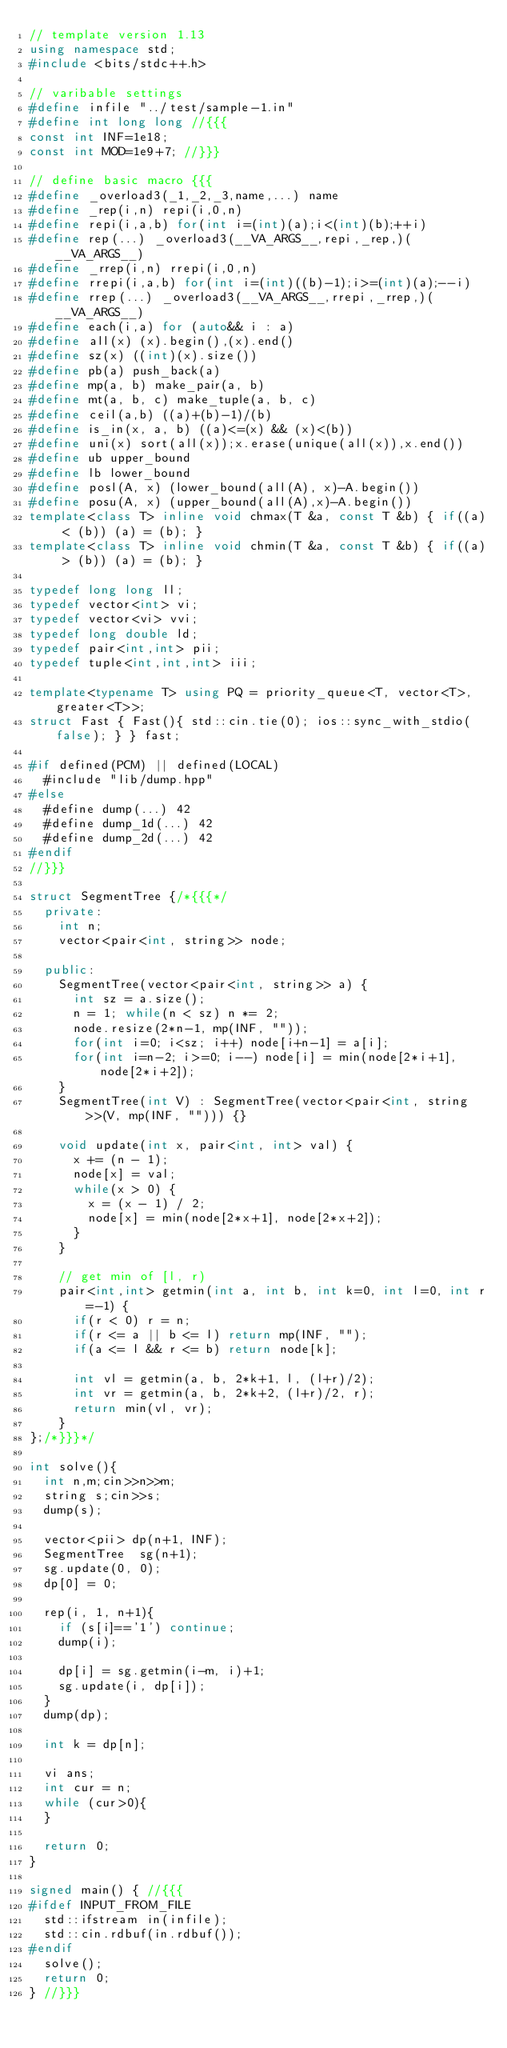<code> <loc_0><loc_0><loc_500><loc_500><_C++_>// template version 1.13
using namespace std;
#include <bits/stdc++.h>

// varibable settings
#define infile "../test/sample-1.in"
#define int long long //{{{
const int INF=1e18;
const int MOD=1e9+7; //}}}

// define basic macro {{{
#define _overload3(_1,_2,_3,name,...) name
#define _rep(i,n) repi(i,0,n)
#define repi(i,a,b) for(int i=(int)(a);i<(int)(b);++i)
#define rep(...) _overload3(__VA_ARGS__,repi,_rep,)(__VA_ARGS__)
#define _rrep(i,n) rrepi(i,0,n)
#define rrepi(i,a,b) for(int i=(int)((b)-1);i>=(int)(a);--i)
#define rrep(...) _overload3(__VA_ARGS__,rrepi,_rrep,)(__VA_ARGS__)
#define each(i,a) for (auto&& i : a)
#define all(x) (x).begin(),(x).end()
#define sz(x) ((int)(x).size())
#define pb(a) push_back(a)
#define mp(a, b) make_pair(a, b)
#define mt(a, b, c) make_tuple(a, b, c)
#define ceil(a,b) ((a)+(b)-1)/(b)
#define is_in(x, a, b) ((a)<=(x) && (x)<(b))
#define uni(x) sort(all(x));x.erase(unique(all(x)),x.end())
#define ub upper_bound
#define lb lower_bound
#define posl(A, x) (lower_bound(all(A), x)-A.begin())
#define posu(A, x) (upper_bound(all(A),x)-A.begin())
template<class T> inline void chmax(T &a, const T &b) { if((a) < (b)) (a) = (b); }
template<class T> inline void chmin(T &a, const T &b) { if((a) > (b)) (a) = (b); }

typedef long long ll;
typedef vector<int> vi;
typedef vector<vi> vvi;
typedef long double ld;
typedef pair<int,int> pii;
typedef tuple<int,int,int> iii;

template<typename T> using PQ = priority_queue<T, vector<T>, greater<T>>;
struct Fast { Fast(){ std::cin.tie(0); ios::sync_with_stdio(false); } } fast;

#if defined(PCM) || defined(LOCAL)
  #include "lib/dump.hpp"
#else
  #define dump(...) 42
  #define dump_1d(...) 42
  #define dump_2d(...) 42
#endif
//}}}

struct SegmentTree {/*{{{*/
  private:
    int n;
    vector<pair<int, string>> node;

  public:
    SegmentTree(vector<pair<int, string>> a) {
      int sz = a.size();
      n = 1; while(n < sz) n *= 2;
      node.resize(2*n-1, mp(INF, ""));
      for(int i=0; i<sz; i++) node[i+n-1] = a[i];
      for(int i=n-2; i>=0; i--) node[i] = min(node[2*i+1], node[2*i+2]);
    }
    SegmentTree(int V) : SegmentTree(vector<pair<int, string>>(V, mp(INF, ""))) {}

    void update(int x, pair<int, int> val) {
      x += (n - 1);
      node[x] = val;
      while(x > 0) {
        x = (x - 1) / 2;
        node[x] = min(node[2*x+1], node[2*x+2]);
      }
    }

    // get min of [l, r)
    pair<int,int> getmin(int a, int b, int k=0, int l=0, int r=-1) {
      if(r < 0) r = n;
      if(r <= a || b <= l) return mp(INF, "");
      if(a <= l && r <= b) return node[k];

      int vl = getmin(a, b, 2*k+1, l, (l+r)/2);
      int vr = getmin(a, b, 2*k+2, (l+r)/2, r);
      return min(vl, vr);
    }
};/*}}}*/

int solve(){
  int n,m;cin>>n>>m;
  string s;cin>>s;
  dump(s);

  vector<pii> dp(n+1, INF);
  SegmentTree  sg(n+1);
  sg.update(0, 0);
  dp[0] = 0;

  rep(i, 1, n+1){
    if (s[i]=='1') continue;
    dump(i);

    dp[i] = sg.getmin(i-m, i)+1;
    sg.update(i, dp[i]);
  }
  dump(dp);

  int k = dp[n];

  vi ans;
  int cur = n;
  while (cur>0){
  }

  return 0;
}

signed main() { //{{{
#ifdef INPUT_FROM_FILE
  std::ifstream in(infile);
  std::cin.rdbuf(in.rdbuf());
#endif
  solve();
  return 0;
} //}}}
</code> 